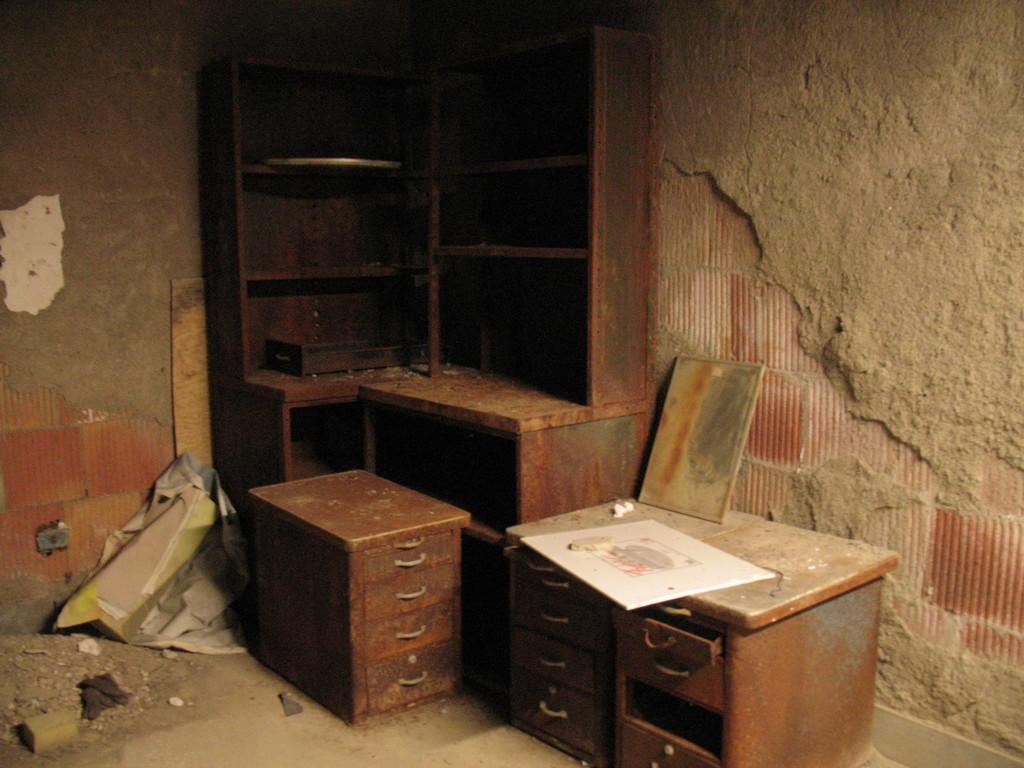What type of structure can be seen in the image? There is a wall in the image. What type of furniture is present in the image? There are cabinets and tables in the image. What type of terrain is visible in the image? There is mud visible in the image. What type of produce is being harvested in the image? There is no produce visible in the image; it only shows a wall, cabinets, tables, and mud. 